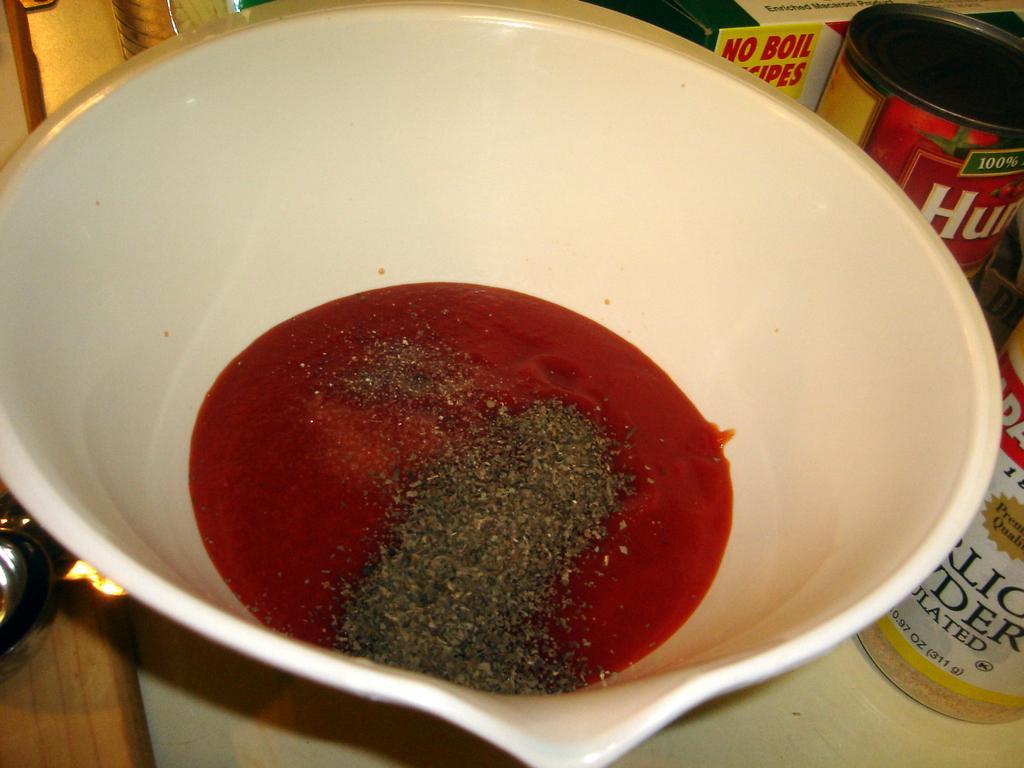In one or two sentences, can you explain what this image depicts? In this picture we can see a bowl. In the bowl we can see liquid and powder. There are bottles and a box on a platform. 